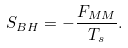Convert formula to latex. <formula><loc_0><loc_0><loc_500><loc_500>S _ { B H } = - \frac { F _ { M M } } { T _ { s } } .</formula> 